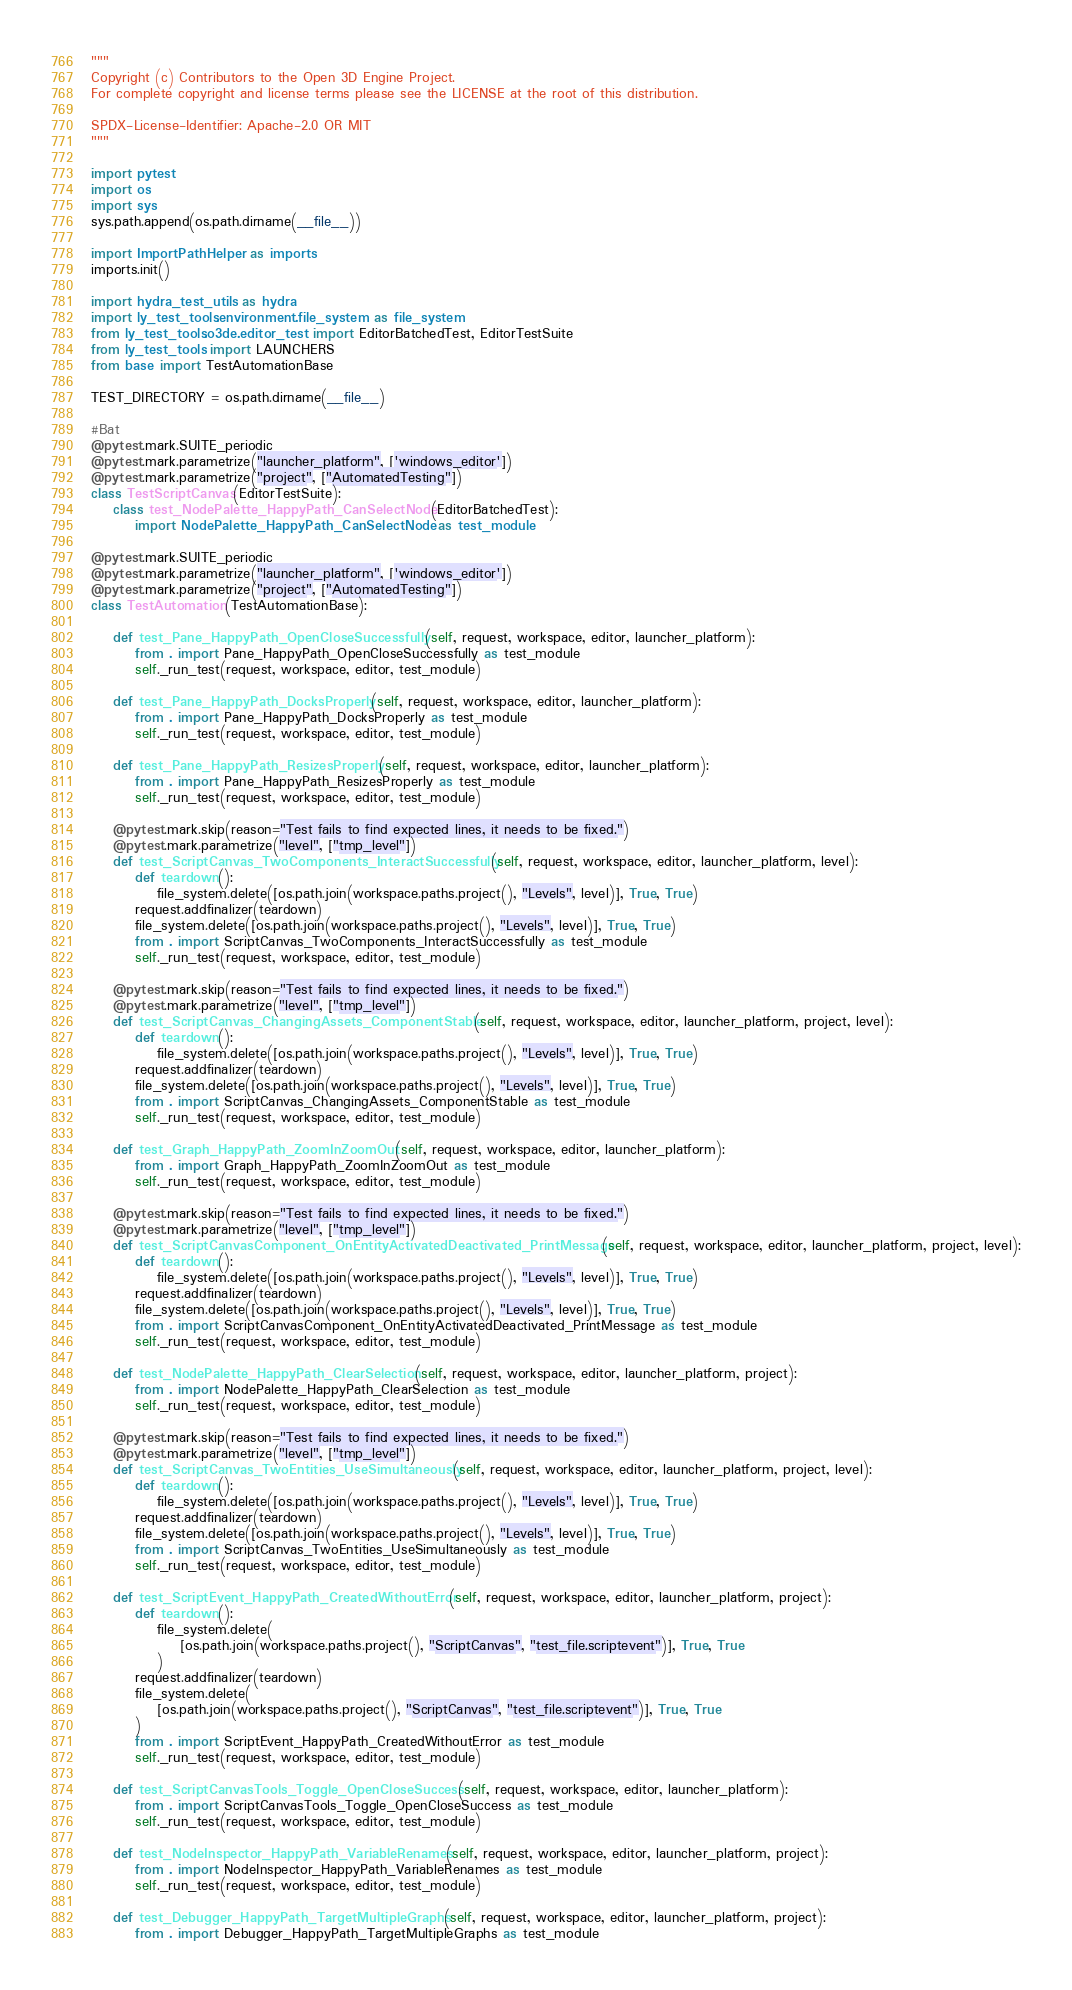<code> <loc_0><loc_0><loc_500><loc_500><_Python_>"""
Copyright (c) Contributors to the Open 3D Engine Project.
For complete copyright and license terms please see the LICENSE at the root of this distribution.

SPDX-License-Identifier: Apache-2.0 OR MIT
"""

import pytest
import os
import sys
sys.path.append(os.path.dirname(__file__))

import ImportPathHelper as imports
imports.init()

import hydra_test_utils as hydra
import ly_test_tools.environment.file_system as file_system
from ly_test_tools.o3de.editor_test import EditorBatchedTest, EditorTestSuite
from ly_test_tools import LAUNCHERS
from base import TestAutomationBase

TEST_DIRECTORY = os.path.dirname(__file__)

#Bat
@pytest.mark.SUITE_periodic
@pytest.mark.parametrize("launcher_platform", ['windows_editor'])
@pytest.mark.parametrize("project", ["AutomatedTesting"])
class TestScriptCanvas(EditorTestSuite):
    class test_NodePalette_HappyPath_CanSelectNode(EditorBatchedTest):
        import NodePalette_HappyPath_CanSelectNode as test_module

@pytest.mark.SUITE_periodic
@pytest.mark.parametrize("launcher_platform", ['windows_editor'])
@pytest.mark.parametrize("project", ["AutomatedTesting"])
class TestAutomation(TestAutomationBase):

    def test_Pane_HappyPath_OpenCloseSuccessfully(self, request, workspace, editor, launcher_platform):
        from . import Pane_HappyPath_OpenCloseSuccessfully as test_module
        self._run_test(request, workspace, editor, test_module)

    def test_Pane_HappyPath_DocksProperly(self, request, workspace, editor, launcher_platform):
        from . import Pane_HappyPath_DocksProperly as test_module
        self._run_test(request, workspace, editor, test_module)

    def test_Pane_HappyPath_ResizesProperly(self, request, workspace, editor, launcher_platform):
        from . import Pane_HappyPath_ResizesProperly as test_module
        self._run_test(request, workspace, editor, test_module)

    @pytest.mark.skip(reason="Test fails to find expected lines, it needs to be fixed.")
    @pytest.mark.parametrize("level", ["tmp_level"])
    def test_ScriptCanvas_TwoComponents_InteractSuccessfully(self, request, workspace, editor, launcher_platform, level):
        def teardown():
            file_system.delete([os.path.join(workspace.paths.project(), "Levels", level)], True, True)
        request.addfinalizer(teardown)
        file_system.delete([os.path.join(workspace.paths.project(), "Levels", level)], True, True)
        from . import ScriptCanvas_TwoComponents_InteractSuccessfully as test_module
        self._run_test(request, workspace, editor, test_module)

    @pytest.mark.skip(reason="Test fails to find expected lines, it needs to be fixed.")
    @pytest.mark.parametrize("level", ["tmp_level"])
    def test_ScriptCanvas_ChangingAssets_ComponentStable(self, request, workspace, editor, launcher_platform, project, level):
        def teardown():
            file_system.delete([os.path.join(workspace.paths.project(), "Levels", level)], True, True)
        request.addfinalizer(teardown)
        file_system.delete([os.path.join(workspace.paths.project(), "Levels", level)], True, True)
        from . import ScriptCanvas_ChangingAssets_ComponentStable as test_module
        self._run_test(request, workspace, editor, test_module)

    def test_Graph_HappyPath_ZoomInZoomOut(self, request, workspace, editor, launcher_platform):
        from . import Graph_HappyPath_ZoomInZoomOut as test_module
        self._run_test(request, workspace, editor, test_module)

    @pytest.mark.skip(reason="Test fails to find expected lines, it needs to be fixed.")
    @pytest.mark.parametrize("level", ["tmp_level"])
    def test_ScriptCanvasComponent_OnEntityActivatedDeactivated_PrintMessage(self, request, workspace, editor, launcher_platform, project, level):
        def teardown():
            file_system.delete([os.path.join(workspace.paths.project(), "Levels", level)], True, True)
        request.addfinalizer(teardown)
        file_system.delete([os.path.join(workspace.paths.project(), "Levels", level)], True, True)
        from . import ScriptCanvasComponent_OnEntityActivatedDeactivated_PrintMessage as test_module
        self._run_test(request, workspace, editor, test_module)

    def test_NodePalette_HappyPath_ClearSelection(self, request, workspace, editor, launcher_platform, project):
        from . import NodePalette_HappyPath_ClearSelection as test_module
        self._run_test(request, workspace, editor, test_module)

    @pytest.mark.skip(reason="Test fails to find expected lines, it needs to be fixed.")
    @pytest.mark.parametrize("level", ["tmp_level"])
    def test_ScriptCanvas_TwoEntities_UseSimultaneously(self, request, workspace, editor, launcher_platform, project, level):
        def teardown():
            file_system.delete([os.path.join(workspace.paths.project(), "Levels", level)], True, True)
        request.addfinalizer(teardown)
        file_system.delete([os.path.join(workspace.paths.project(), "Levels", level)], True, True)
        from . import ScriptCanvas_TwoEntities_UseSimultaneously as test_module
        self._run_test(request, workspace, editor, test_module)

    def test_ScriptEvent_HappyPath_CreatedWithoutError(self, request, workspace, editor, launcher_platform, project):
        def teardown():
            file_system.delete(
                [os.path.join(workspace.paths.project(), "ScriptCanvas", "test_file.scriptevent")], True, True
            )
        request.addfinalizer(teardown)
        file_system.delete(
            [os.path.join(workspace.paths.project(), "ScriptCanvas", "test_file.scriptevent")], True, True
        )
        from . import ScriptEvent_HappyPath_CreatedWithoutError as test_module
        self._run_test(request, workspace, editor, test_module)

    def test_ScriptCanvasTools_Toggle_OpenCloseSuccess(self, request, workspace, editor, launcher_platform):
        from . import ScriptCanvasTools_Toggle_OpenCloseSuccess as test_module
        self._run_test(request, workspace, editor, test_module)

    def test_NodeInspector_HappyPath_VariableRenames(self, request, workspace, editor, launcher_platform, project):
        from . import NodeInspector_HappyPath_VariableRenames as test_module
        self._run_test(request, workspace, editor, test_module)

    def test_Debugger_HappyPath_TargetMultipleGraphs(self, request, workspace, editor, launcher_platform, project):
        from . import Debugger_HappyPath_TargetMultipleGraphs as test_module</code> 